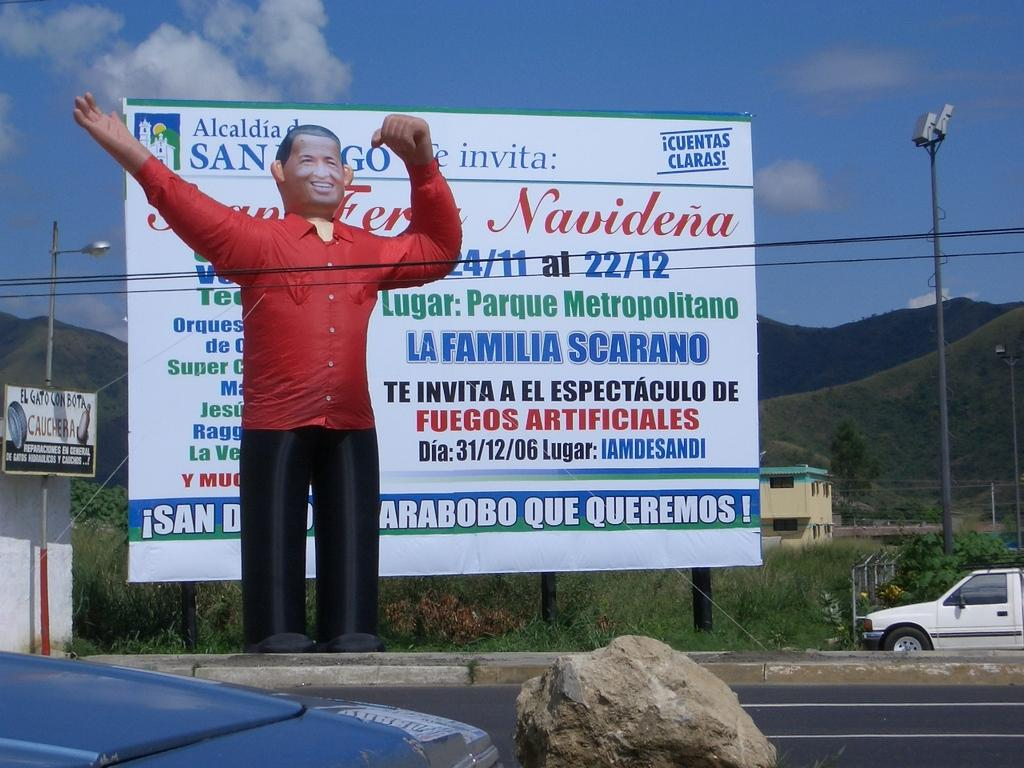<image>
Summarize the visual content of the image. The billboard behind the fake person is for La Familia Scarano. 